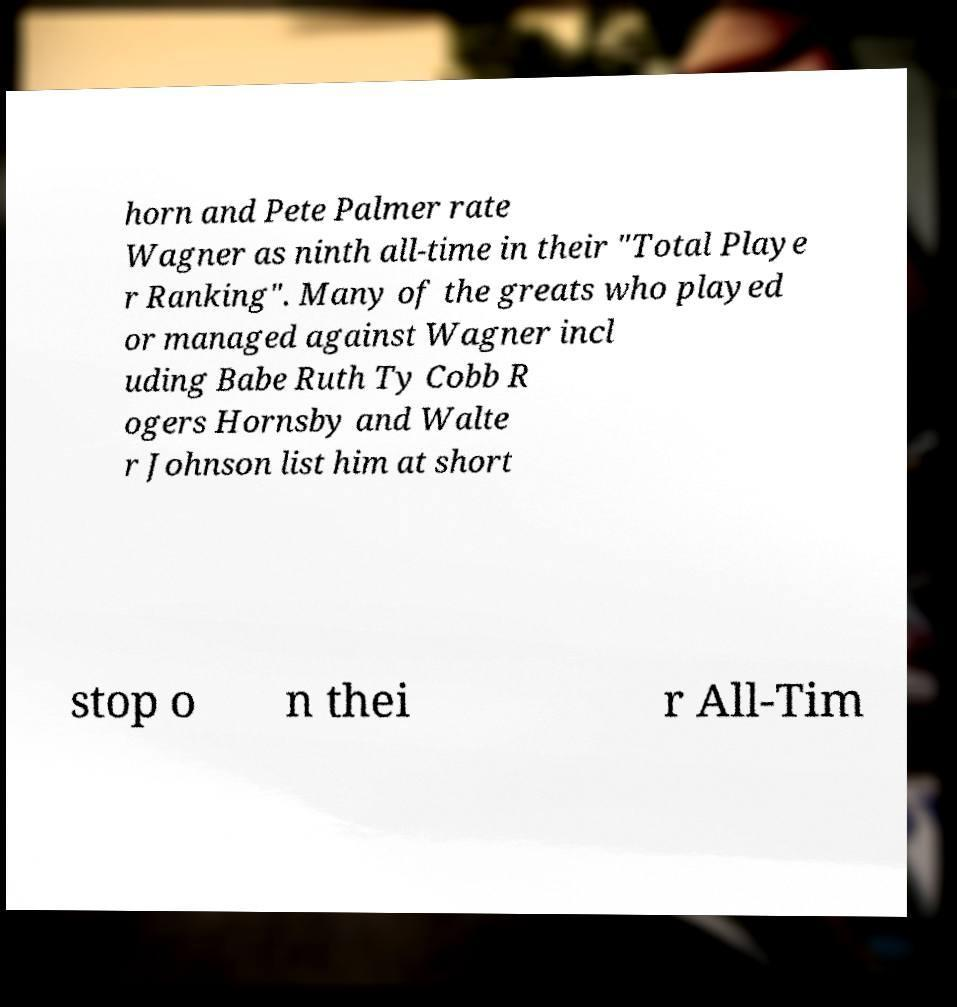I need the written content from this picture converted into text. Can you do that? horn and Pete Palmer rate Wagner as ninth all-time in their "Total Playe r Ranking". Many of the greats who played or managed against Wagner incl uding Babe Ruth Ty Cobb R ogers Hornsby and Walte r Johnson list him at short stop o n thei r All-Tim 